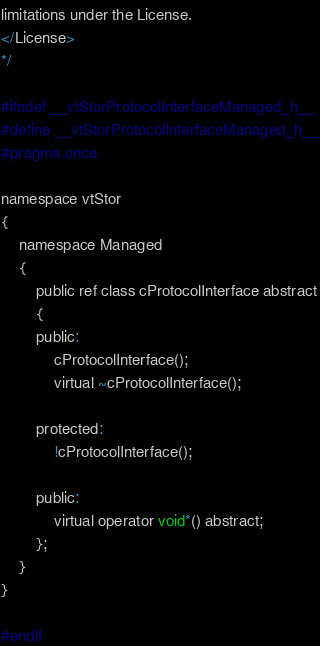<code> <loc_0><loc_0><loc_500><loc_500><_C_>limitations under the License.
</License>
*/

#ifndef __vtStorProtocolInterfaceManaged_h__
#define __vtStorProtocolInterfaceManaged_h__
#pragma once

namespace vtStor
{
    namespace Managed
    {
        public ref class cProtocolInterface abstract
        {
        public:
            cProtocolInterface();
            virtual ~cProtocolInterface();

        protected:
            !cProtocolInterface();

        public:
            virtual operator void*() abstract;
        };
    }
}

#endif</code> 